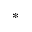<formula> <loc_0><loc_0><loc_500><loc_500>^ { * }</formula> 